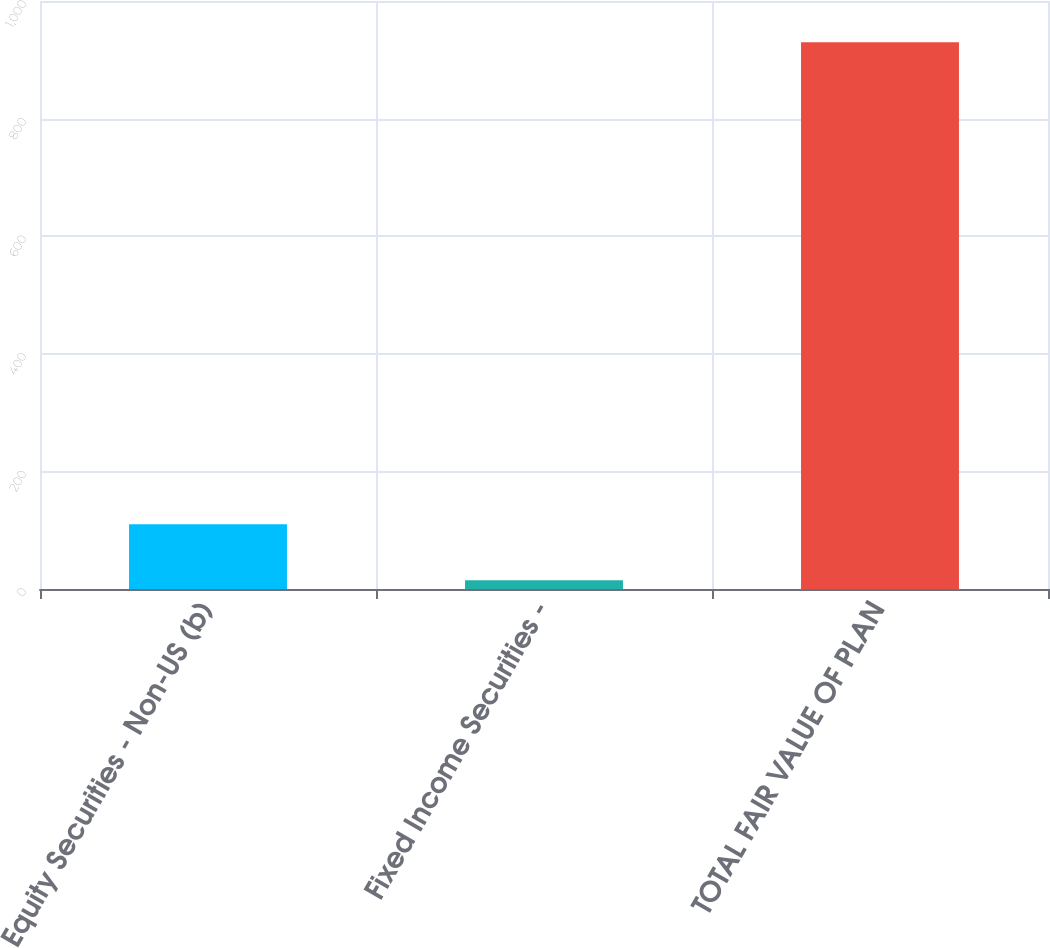Convert chart to OTSL. <chart><loc_0><loc_0><loc_500><loc_500><bar_chart><fcel>Equity Securities - Non-US (b)<fcel>Fixed Income Securities -<fcel>TOTAL FAIR VALUE OF PLAN<nl><fcel>110<fcel>15<fcel>930<nl></chart> 